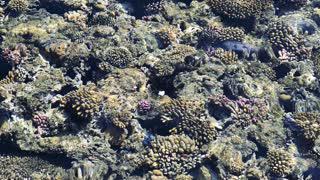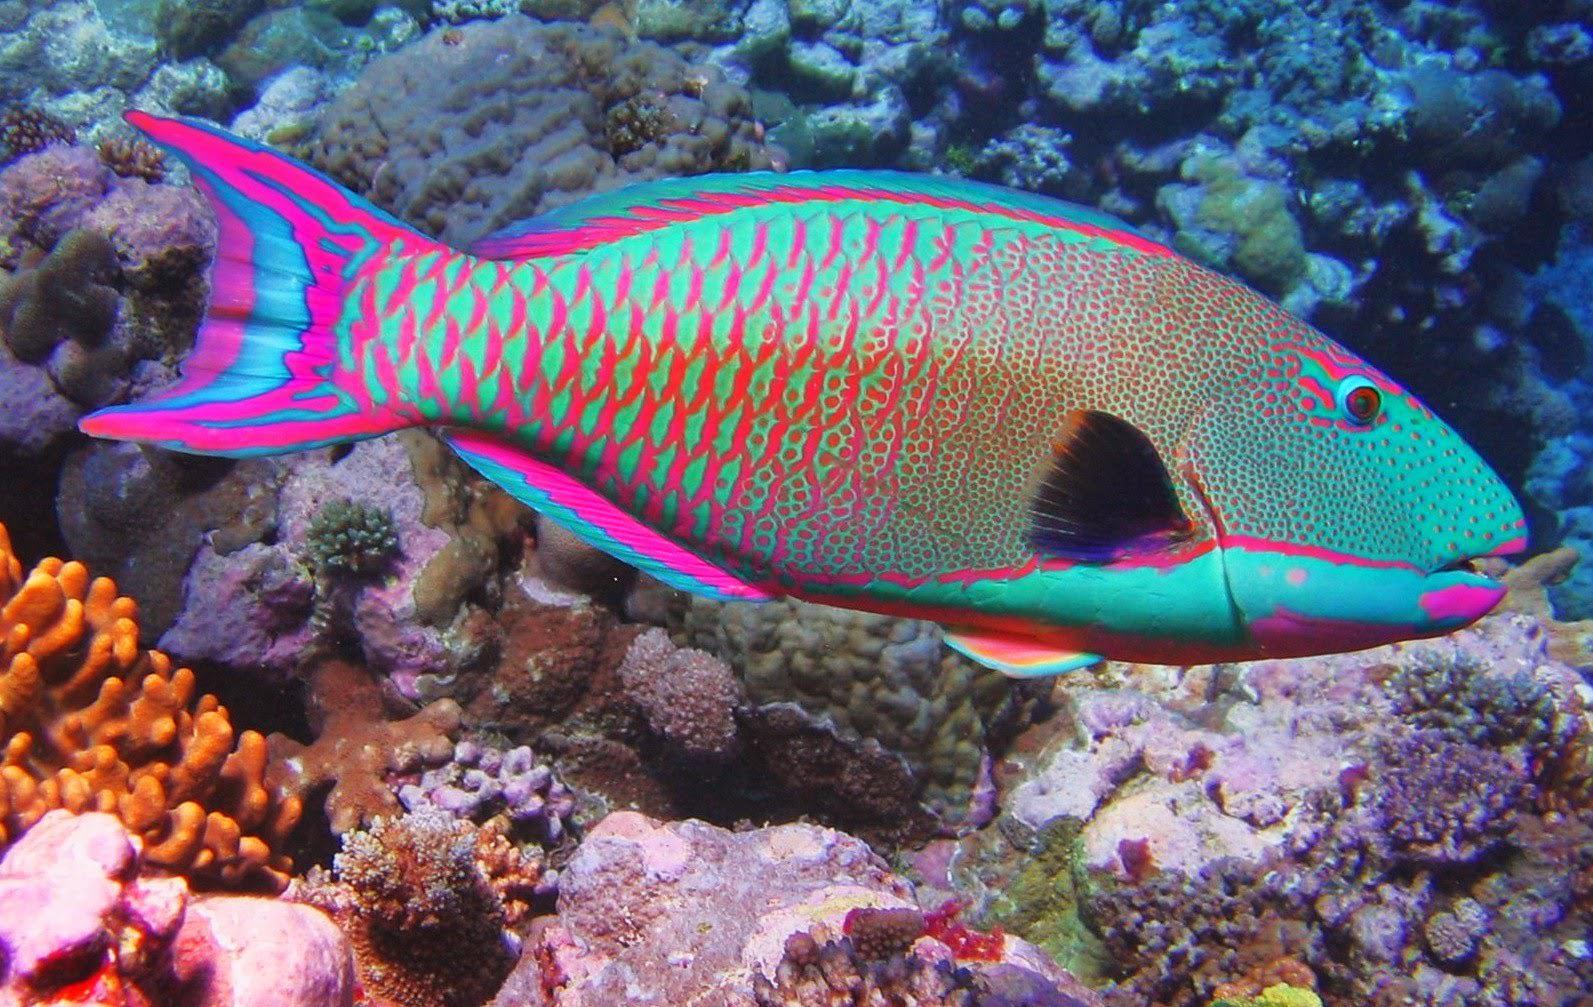The first image is the image on the left, the second image is the image on the right. For the images displayed, is the sentence "The right image shows a single prominent fish displayed in profile with some blue coloring, and the left image shows beds of coral or anemone with no fish present and with touches of violet color." factually correct? Answer yes or no. Yes. The first image is the image on the left, the second image is the image on the right. For the images shown, is this caption "Some fish are facing toward the right." true? Answer yes or no. Yes. 